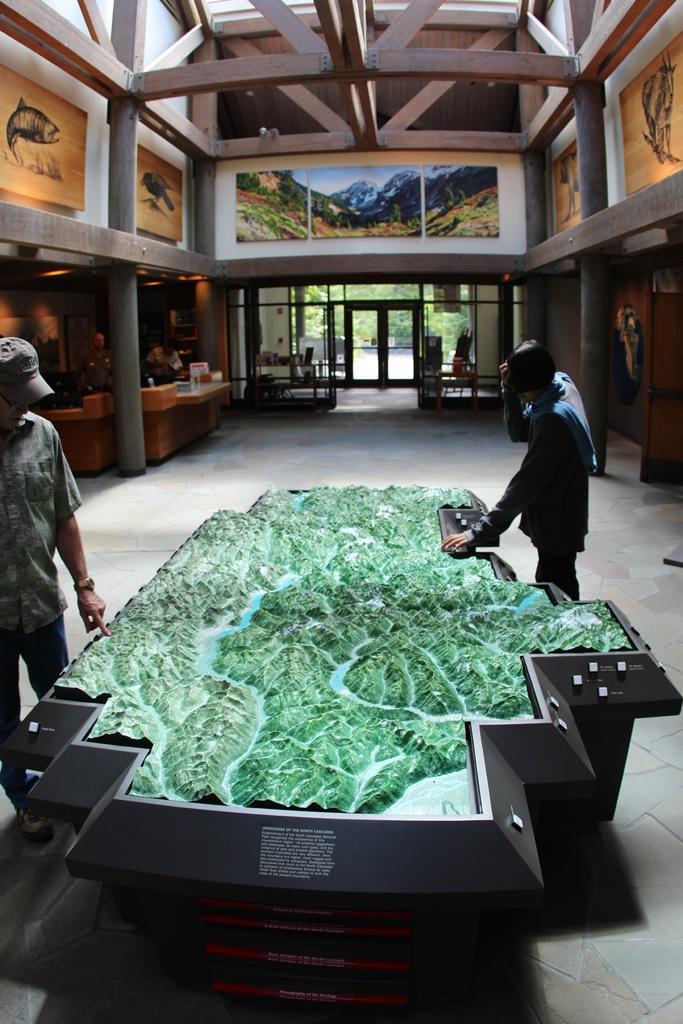Could you give a brief overview of what you see in this image? In this image there are some people and in the center there is some object, and in the background there are some poles, glass windows, boards and some wooden sticks and some other objects. At the bottom there is floor, and at the top there is ceiling. 